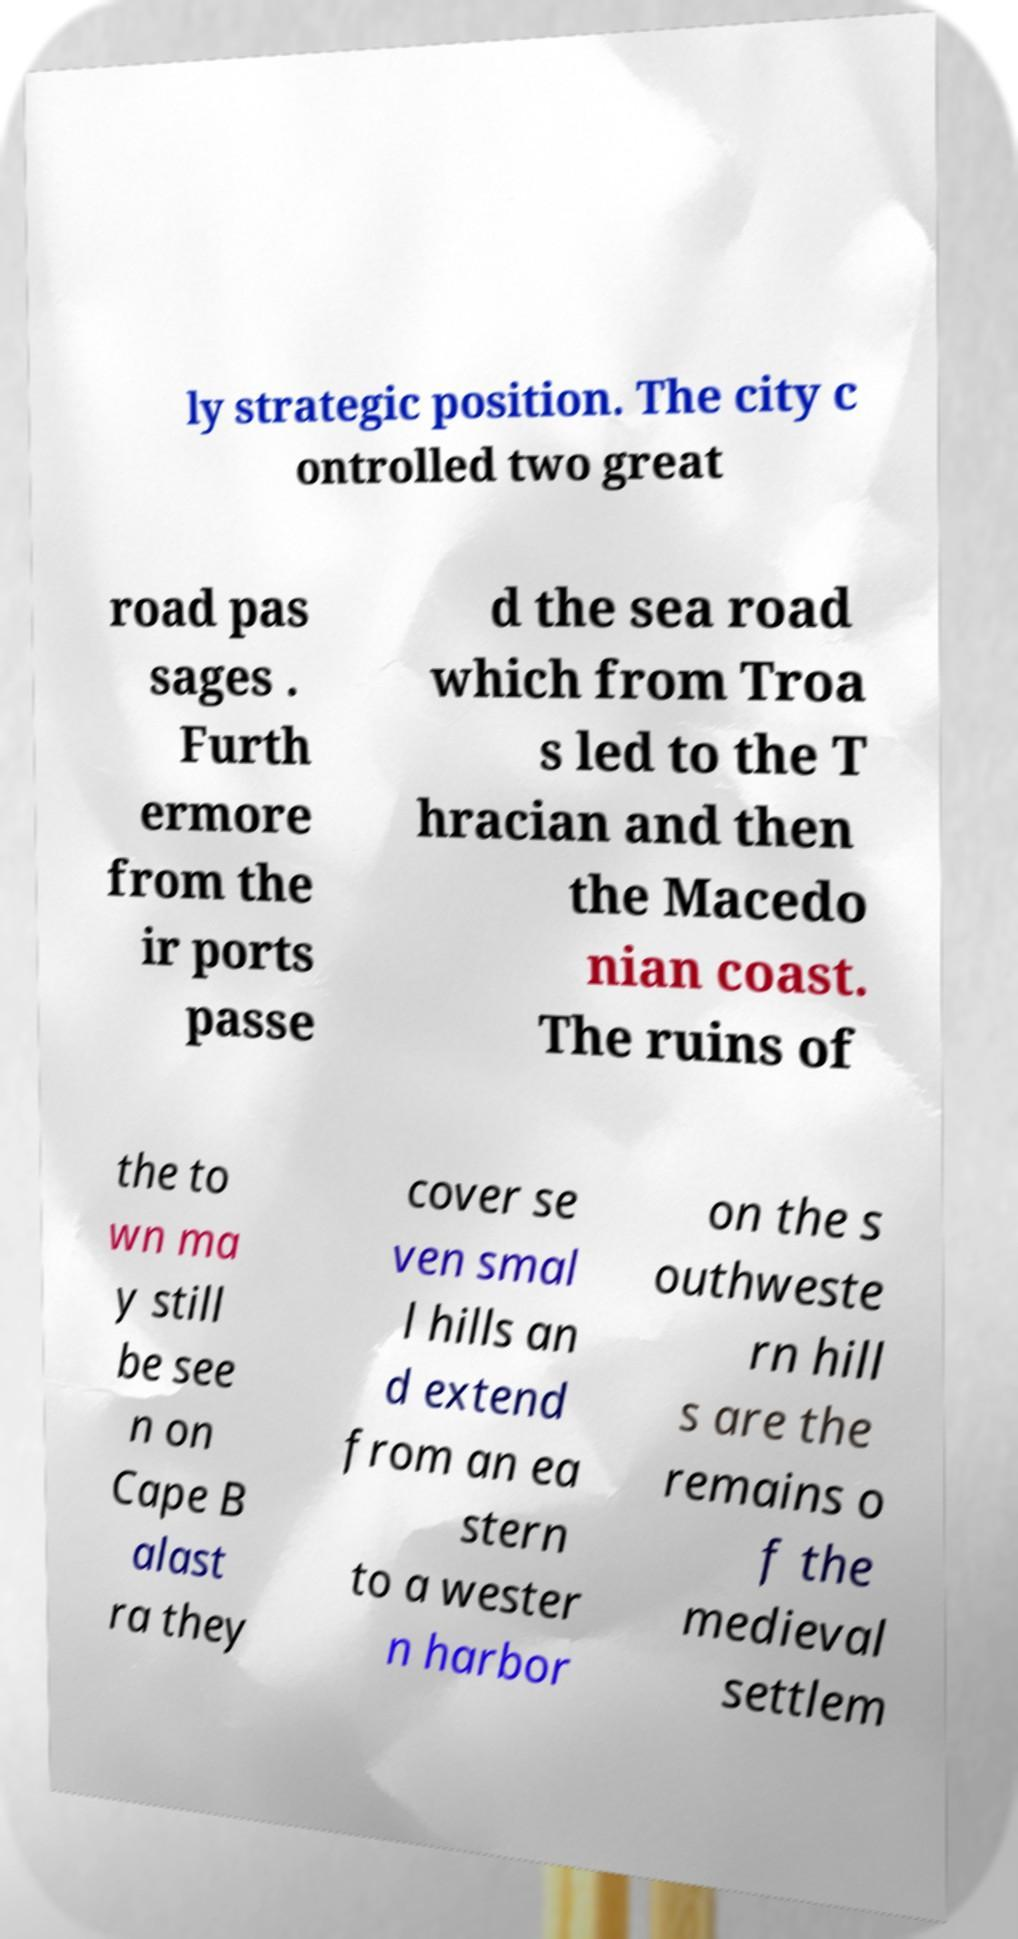What messages or text are displayed in this image? I need them in a readable, typed format. ly strategic position. The city c ontrolled two great road pas sages . Furth ermore from the ir ports passe d the sea road which from Troa s led to the T hracian and then the Macedo nian coast. The ruins of the to wn ma y still be see n on Cape B alast ra they cover se ven smal l hills an d extend from an ea stern to a wester n harbor on the s outhweste rn hill s are the remains o f the medieval settlem 